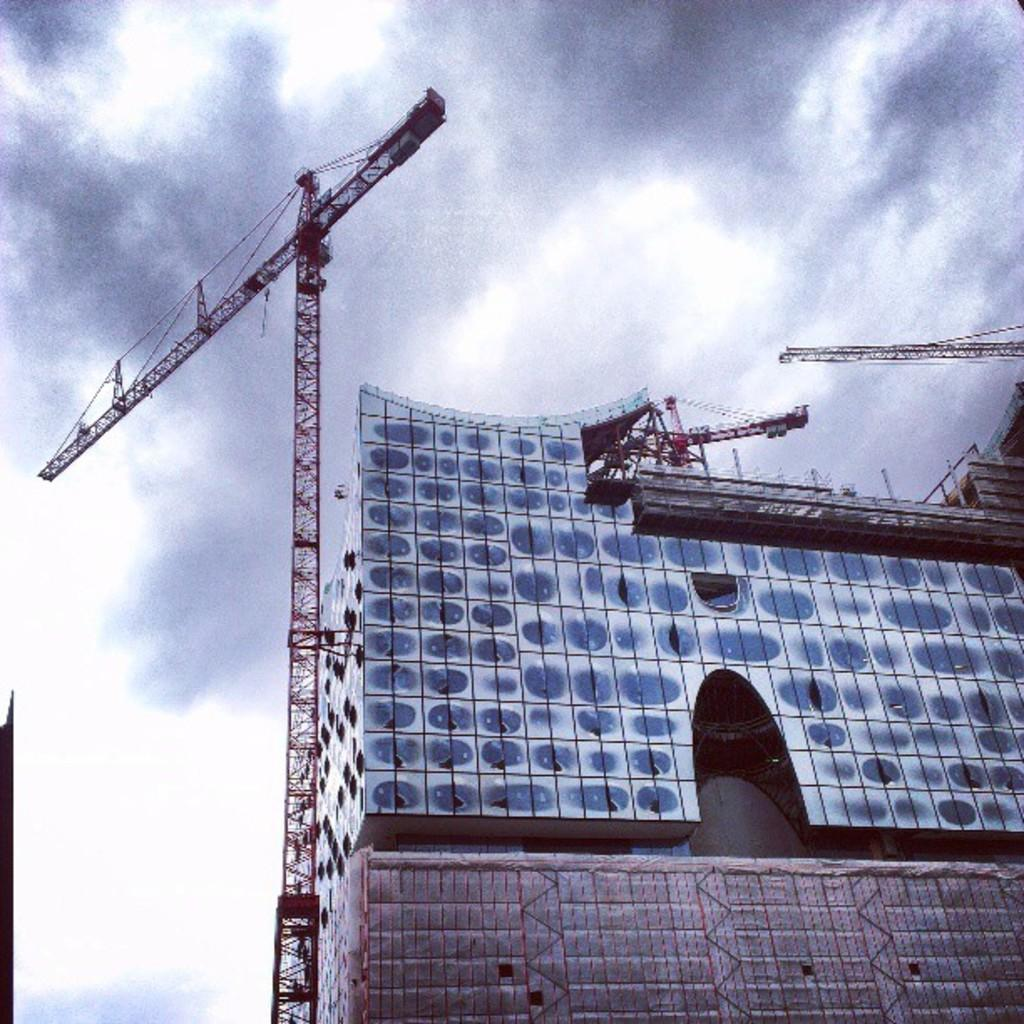What building is featured in the image? The Elbe philharmonic hall is in the image. How much income does the letter in the image generate? There is no letter present in the image, so it is not possible to determine its income. 